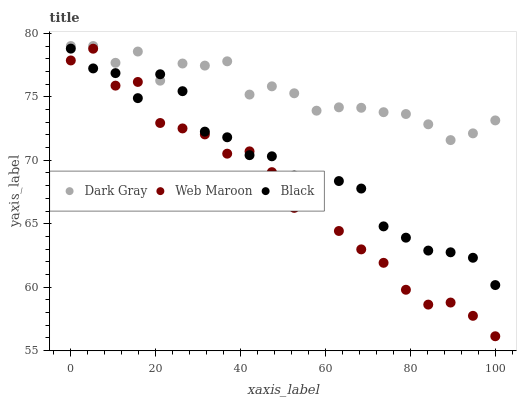Does Web Maroon have the minimum area under the curve?
Answer yes or no. Yes. Does Dark Gray have the maximum area under the curve?
Answer yes or no. Yes. Does Black have the minimum area under the curve?
Answer yes or no. No. Does Black have the maximum area under the curve?
Answer yes or no. No. Is Dark Gray the smoothest?
Answer yes or no. Yes. Is Web Maroon the roughest?
Answer yes or no. Yes. Is Black the smoothest?
Answer yes or no. No. Is Black the roughest?
Answer yes or no. No. Does Web Maroon have the lowest value?
Answer yes or no. Yes. Does Black have the lowest value?
Answer yes or no. No. Does Dark Gray have the highest value?
Answer yes or no. Yes. Does Black have the highest value?
Answer yes or no. No. Is Web Maroon less than Dark Gray?
Answer yes or no. Yes. Is Dark Gray greater than Web Maroon?
Answer yes or no. Yes. Does Black intersect Dark Gray?
Answer yes or no. Yes. Is Black less than Dark Gray?
Answer yes or no. No. Is Black greater than Dark Gray?
Answer yes or no. No. Does Web Maroon intersect Dark Gray?
Answer yes or no. No. 